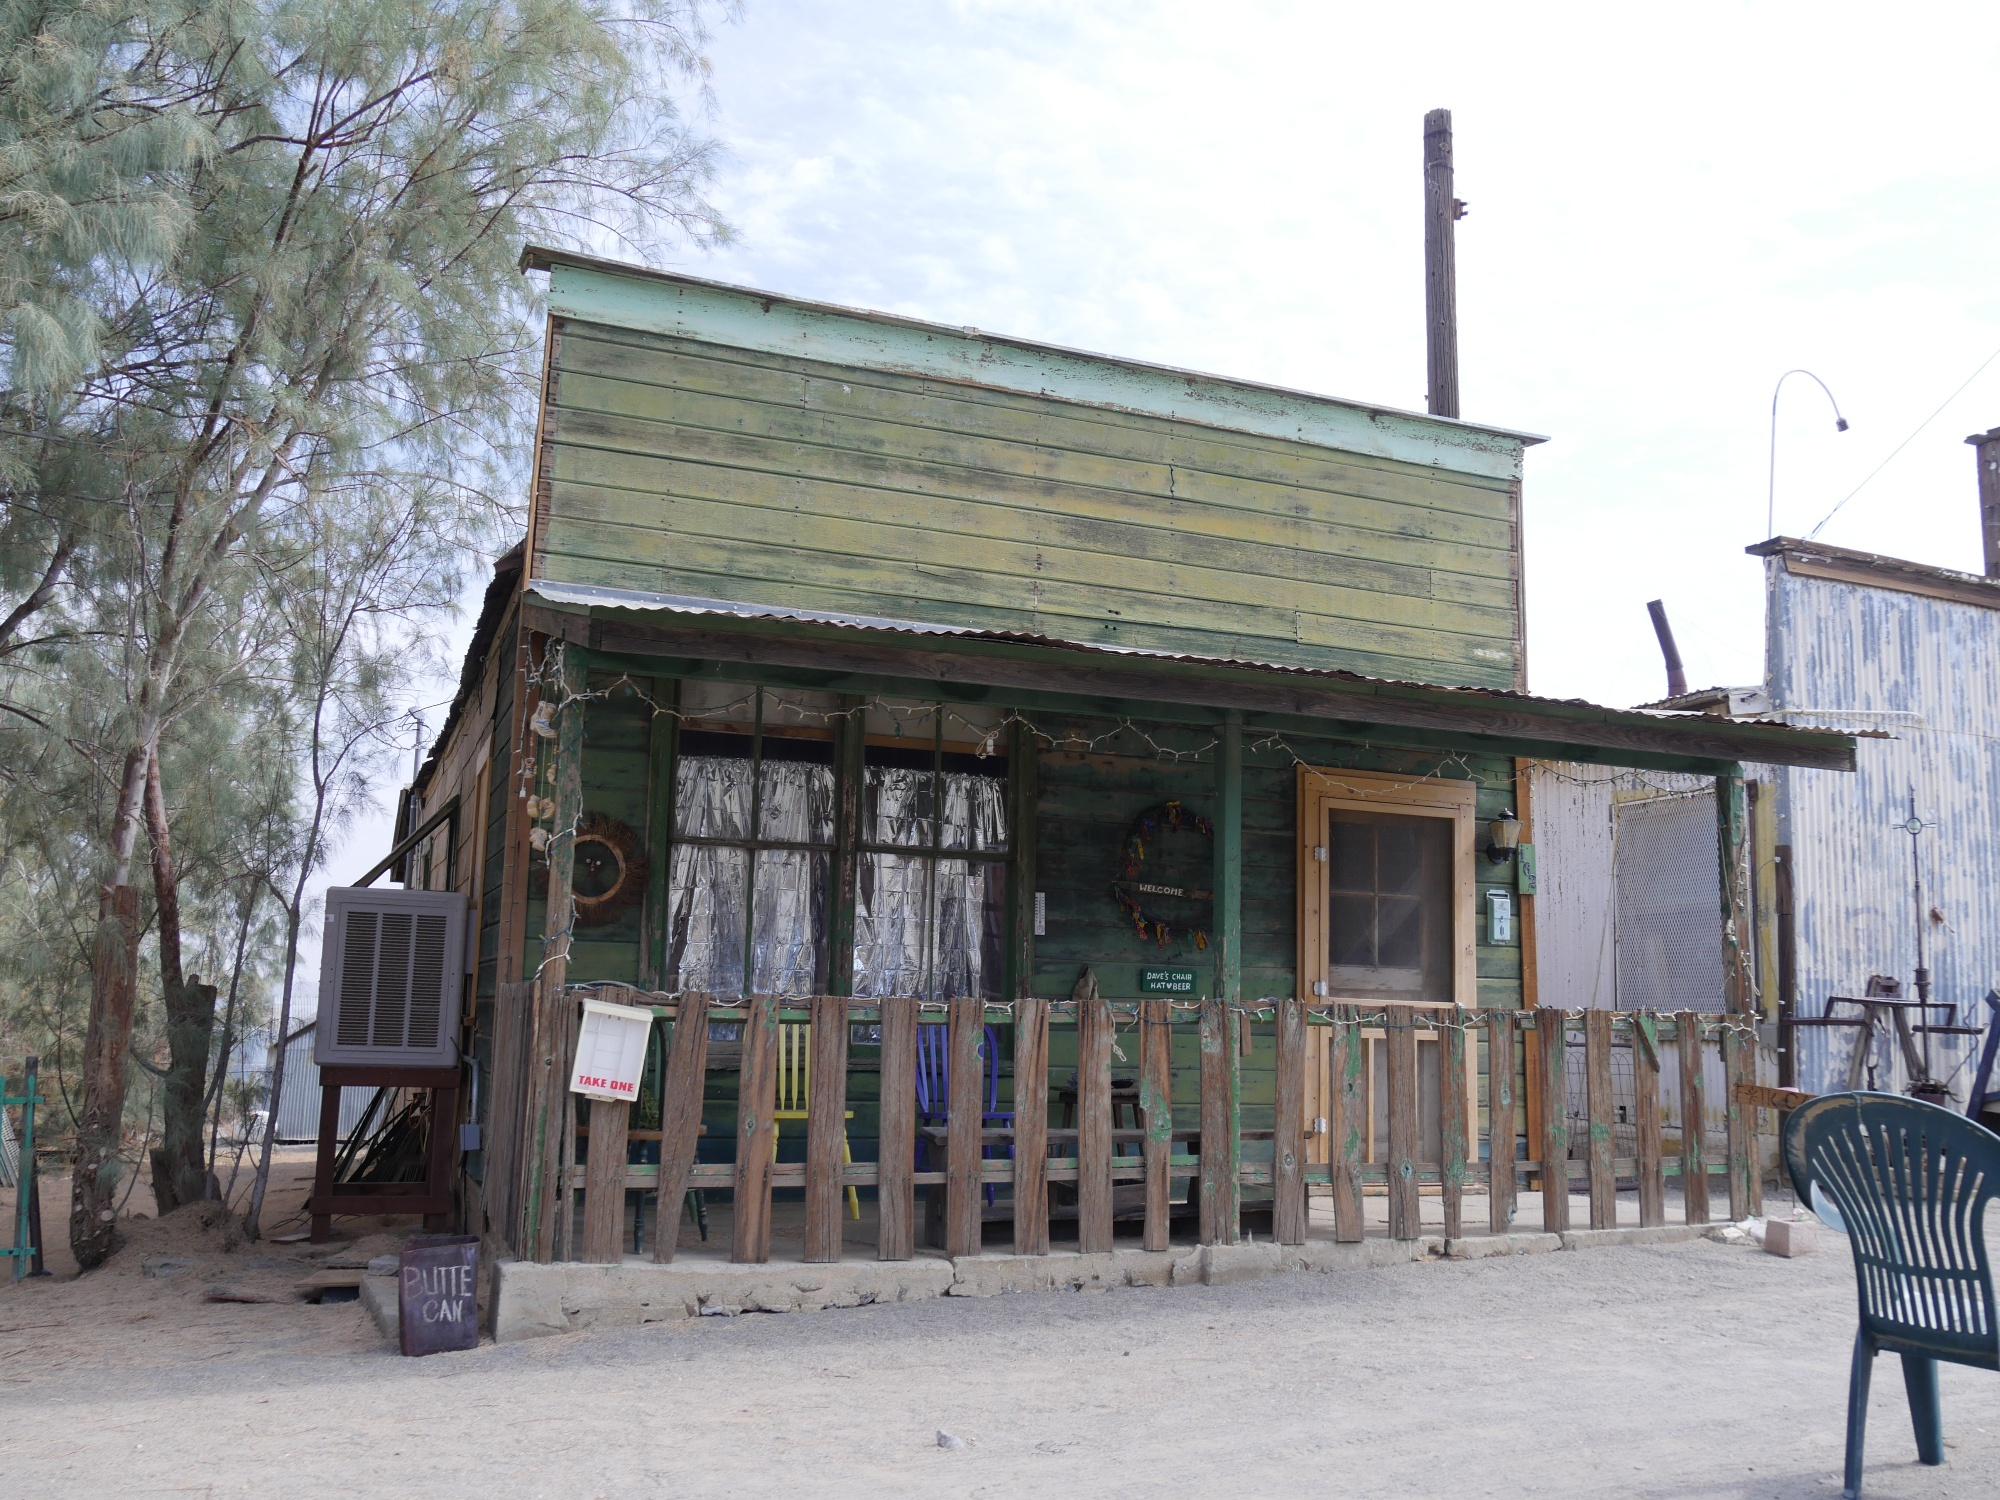Describe the atmosphere and mood of the scene. The atmosphere of the scene is one of quiet abandonment and nostalgia. The dilapidated state of the building, with its peeling paint and run-down appearance, coupled with the scattered objects, suggests a place that was once lived in and loved but has since been forgotten. The sign for 'Route 66' imbues the scene with a sense of history and adventure, hinting at past journeys and stories. The overall mood is melancholic yet serene, with the surrounding greenery adding a touch of hope and renewal amid the decay. 